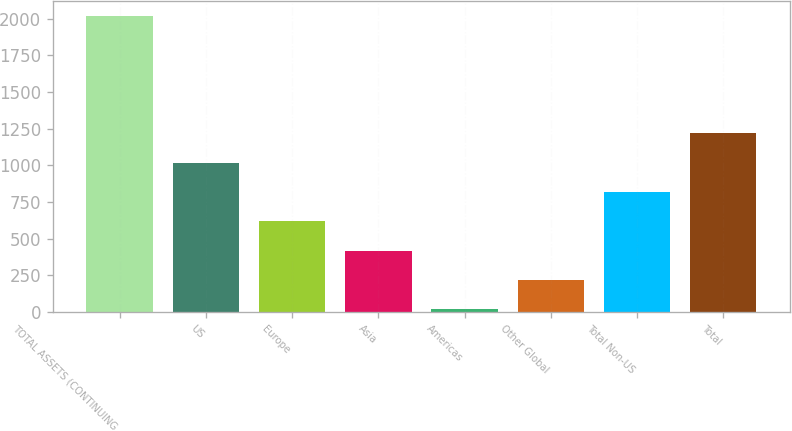<chart> <loc_0><loc_0><loc_500><loc_500><bar_chart><fcel>TOTAL ASSETS (CONTINUING<fcel>US<fcel>Europe<fcel>Asia<fcel>Americas<fcel>Other Global<fcel>Total Non-US<fcel>Total<nl><fcel>2018<fcel>1018<fcel>618<fcel>418<fcel>18<fcel>218<fcel>818<fcel>1218<nl></chart> 